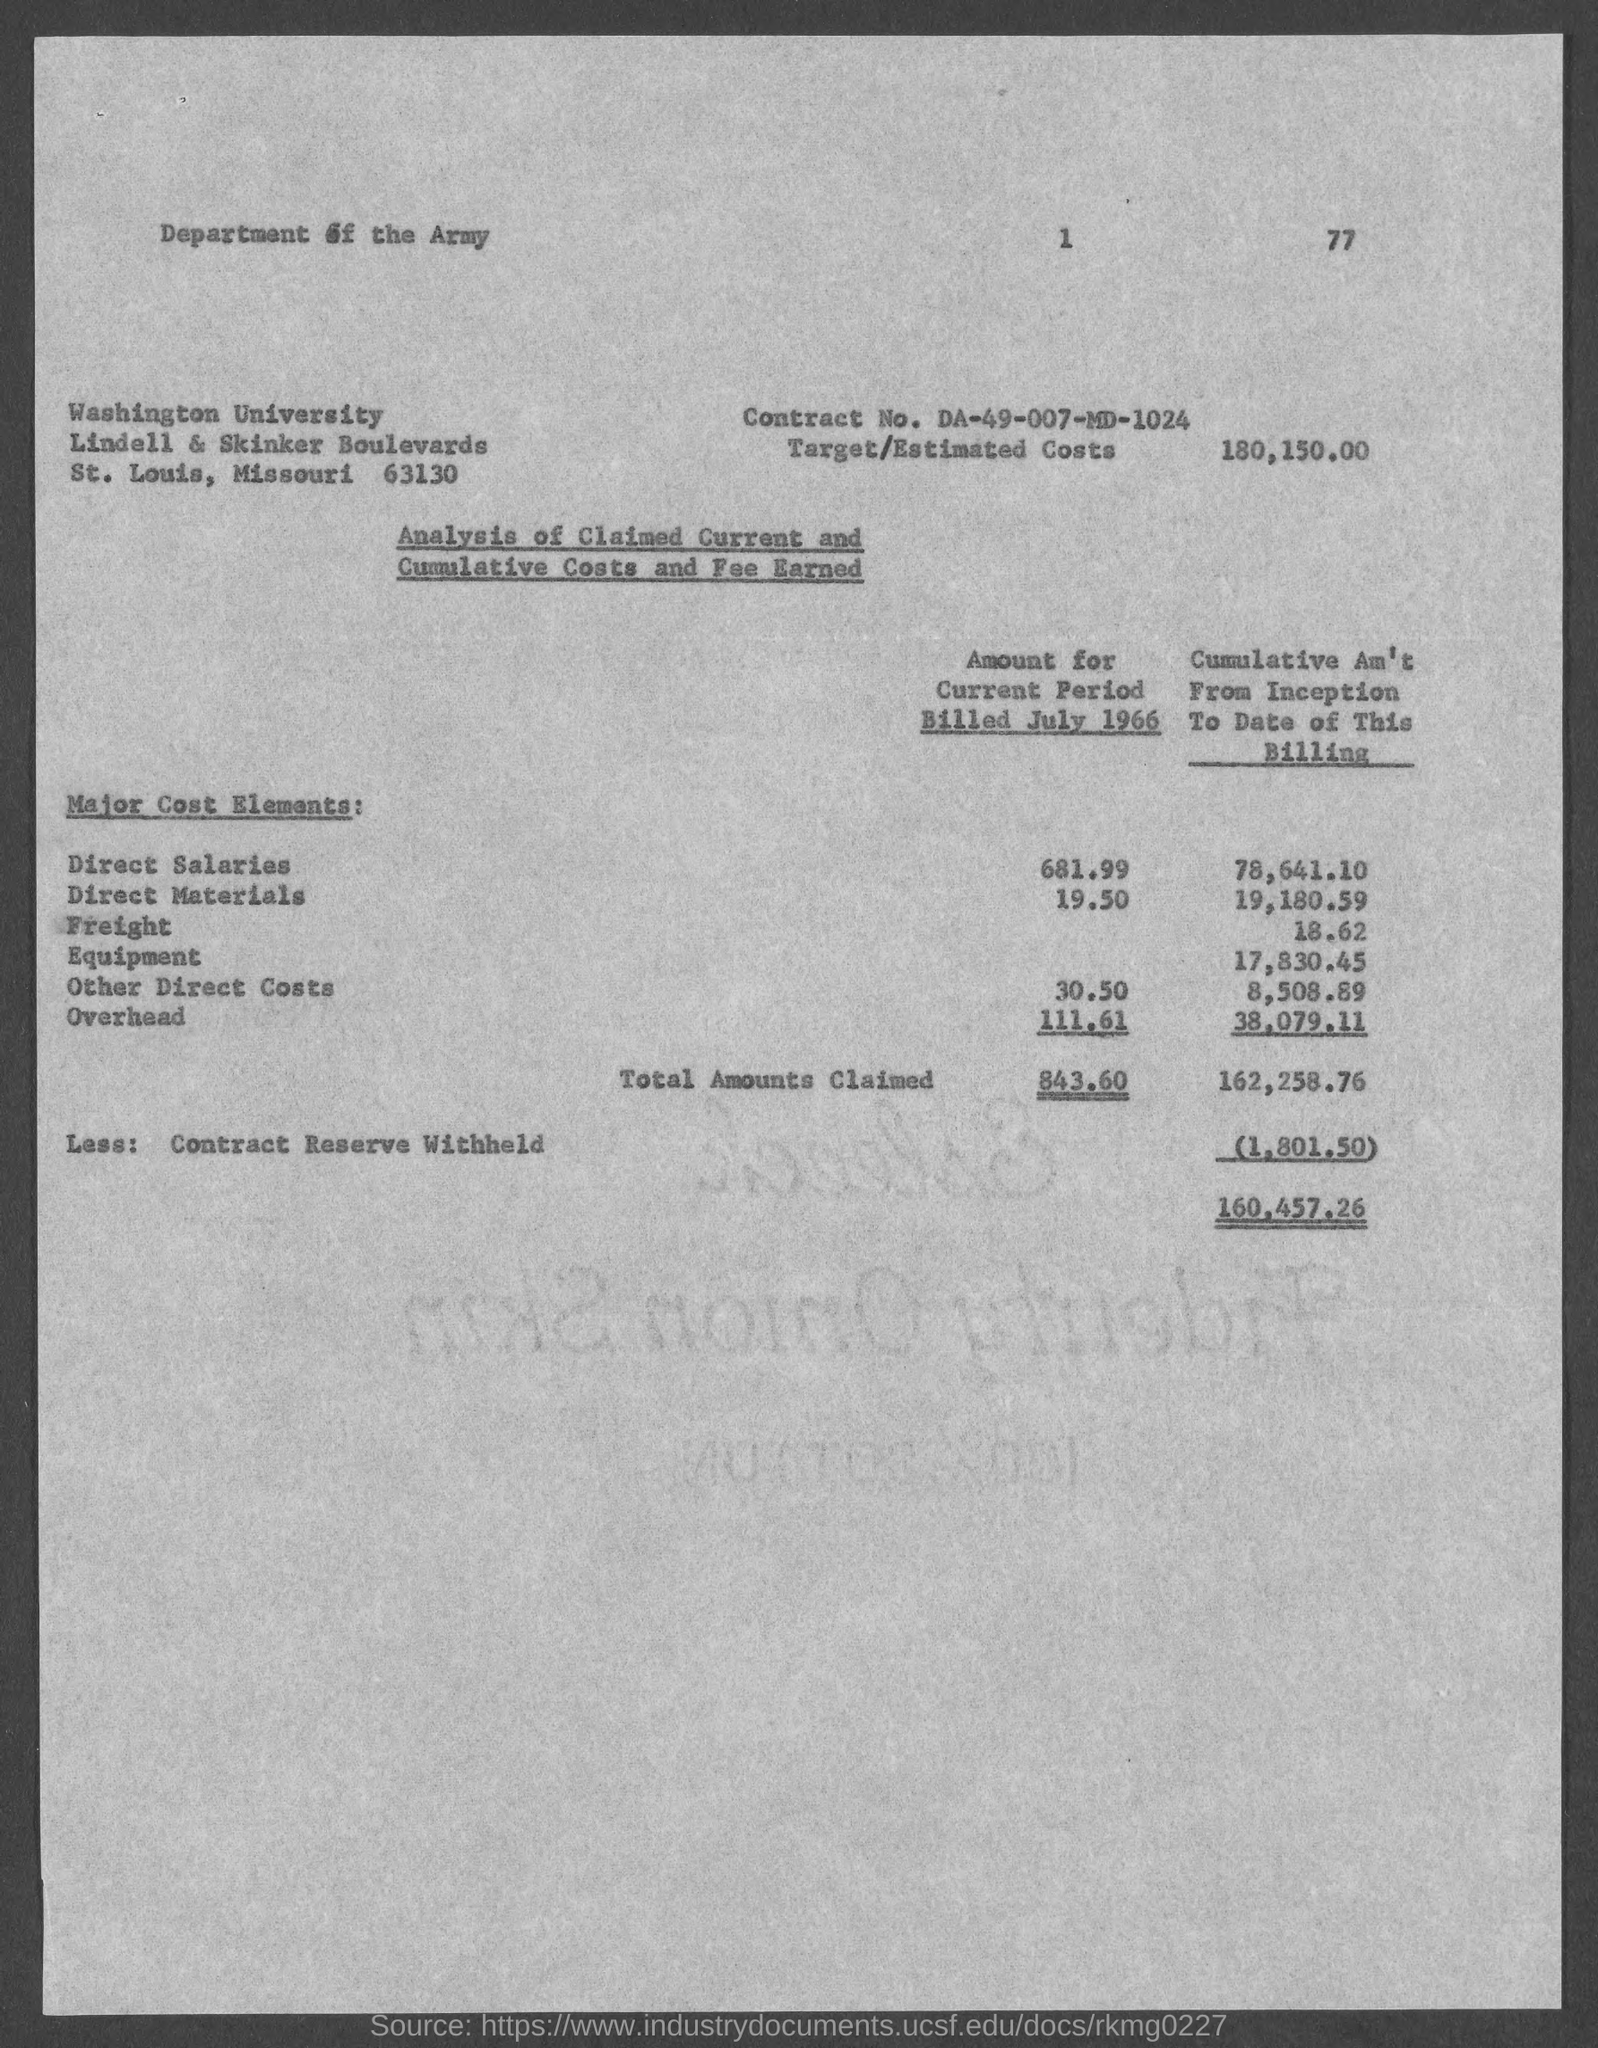Indicate a few pertinent items in this graphic. The street address of Washington University is located at Lindell & Skinker Boulevards. The contract number is DA-49-007-MD-1024. Washington University is located in St. Louis County. Our target/estimated costs are $180,150.00. 